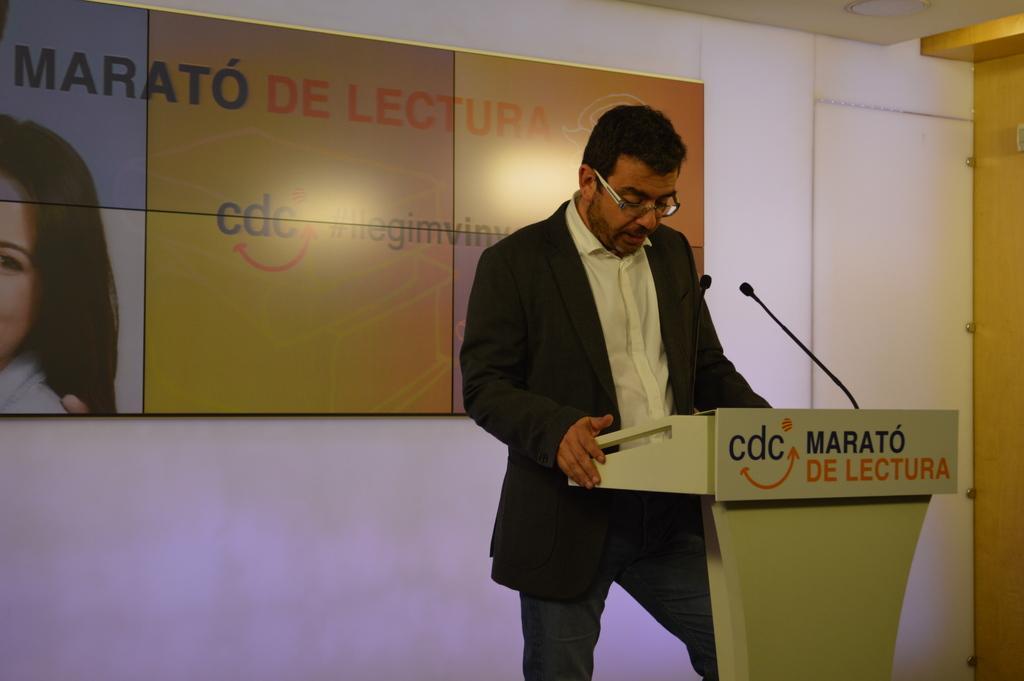How would you summarize this image in a sentence or two? In this picture we can see a man standing in front of a podium, there are two microphones on the podium, in the background there is a board, we can see some text on the board. 